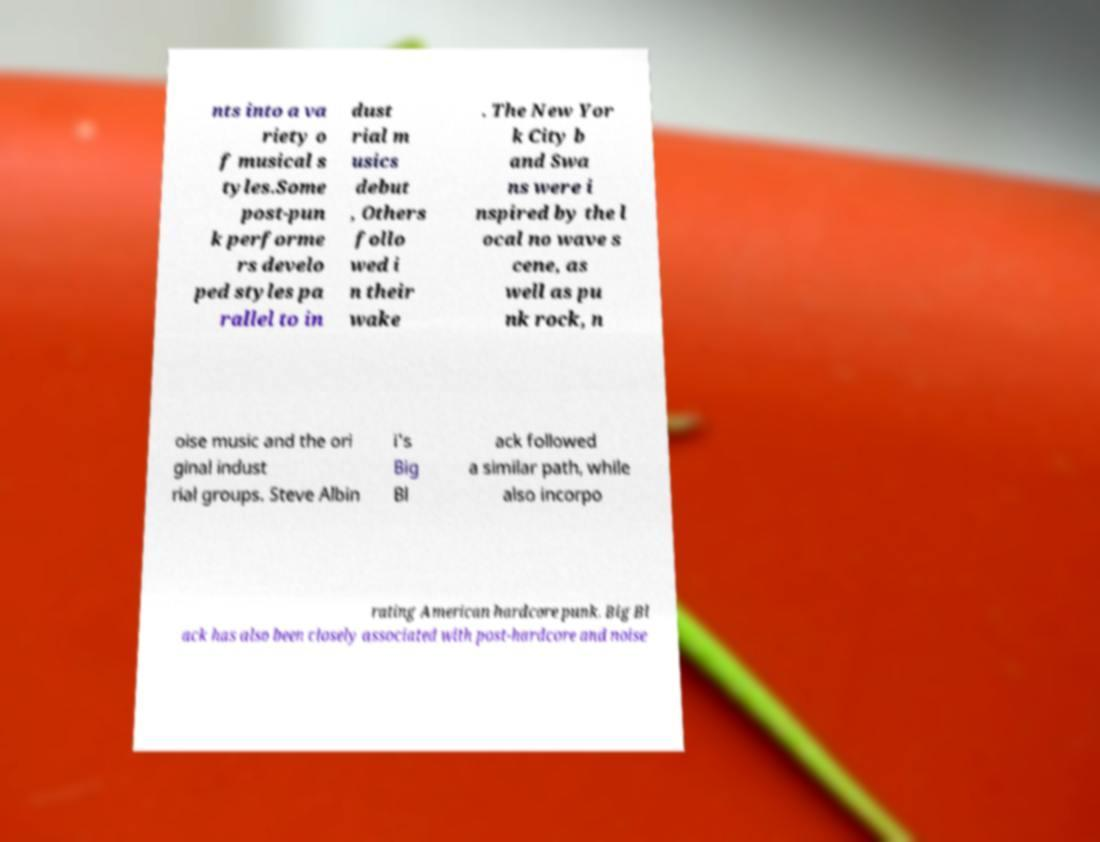Can you read and provide the text displayed in the image?This photo seems to have some interesting text. Can you extract and type it out for me? nts into a va riety o f musical s tyles.Some post-pun k performe rs develo ped styles pa rallel to in dust rial m usics debut , Others follo wed i n their wake . The New Yor k City b and Swa ns were i nspired by the l ocal no wave s cene, as well as pu nk rock, n oise music and the ori ginal indust rial groups. Steve Albin i's Big Bl ack followed a similar path, while also incorpo rating American hardcore punk. Big Bl ack has also been closely associated with post-hardcore and noise 